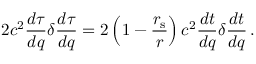<formula> <loc_0><loc_0><loc_500><loc_500>2 c ^ { 2 } { \frac { d \tau } { d q } } \delta { \frac { d \tau } { d q } } = 2 \left ( 1 - { \frac { r _ { s } } { r } } \right ) c ^ { 2 } { \frac { d t } { d q } } \delta { \frac { d t } { d q } } \, .</formula> 